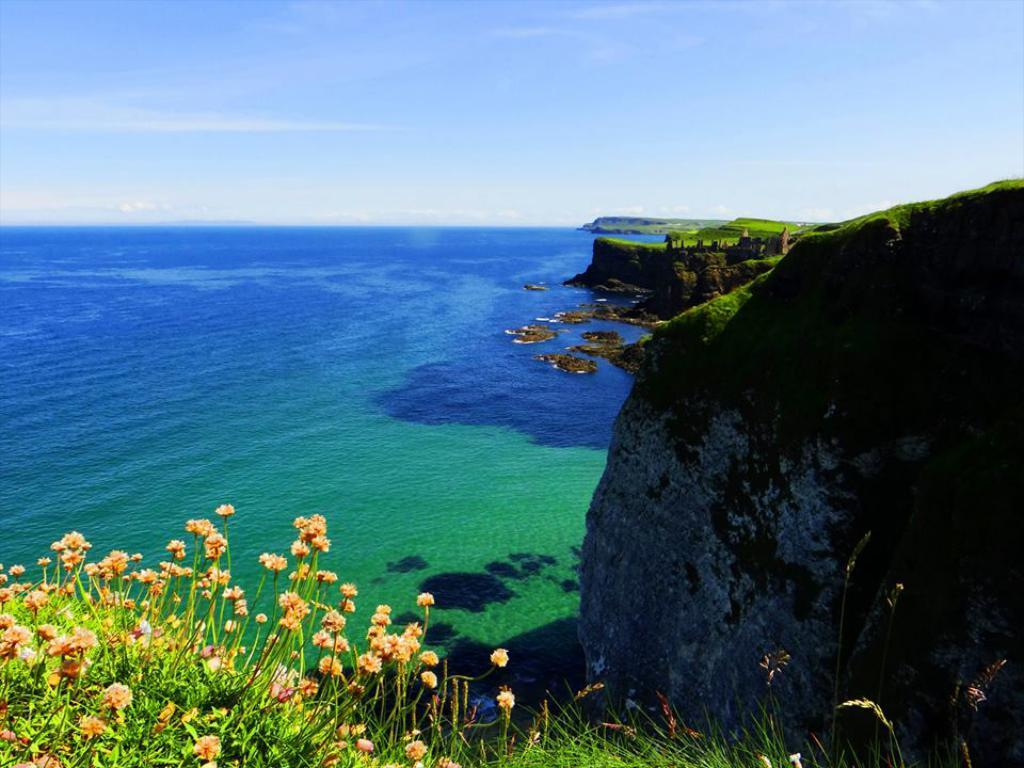What type of plants can be seen in the image? There are plants with flowers in the image. What else is visible in the image besides the plants? There is water visible in the image. What can be seen in the background of the image? The sky is visible in the background of the image. How many chickens are present in the image? There are no chickens present in the image. What type of mitten is being used to water the plants in the image? There is no mitten visible in the image, and the plants do not appear to be watered. 